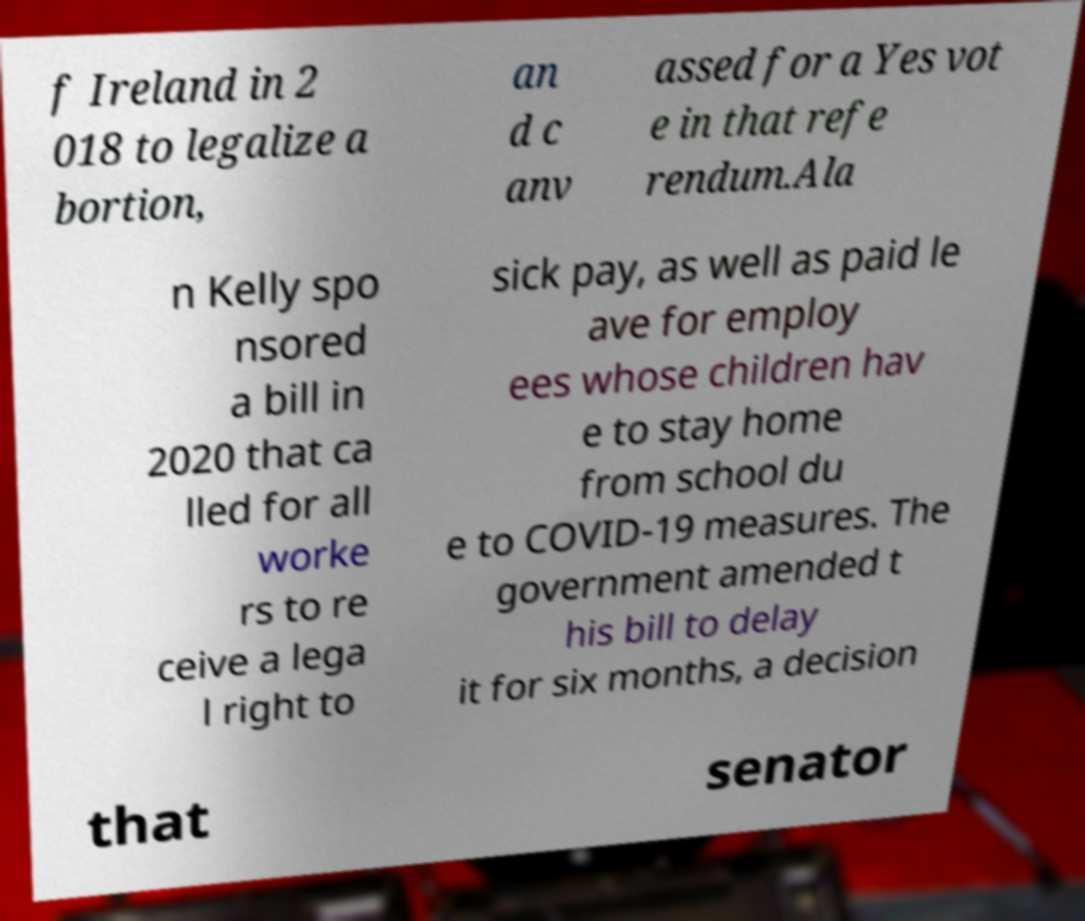Can you accurately transcribe the text from the provided image for me? f Ireland in 2 018 to legalize a bortion, an d c anv assed for a Yes vot e in that refe rendum.Ala n Kelly spo nsored a bill in 2020 that ca lled for all worke rs to re ceive a lega l right to sick pay, as well as paid le ave for employ ees whose children hav e to stay home from school du e to COVID-19 measures. The government amended t his bill to delay it for six months, a decision that senator 